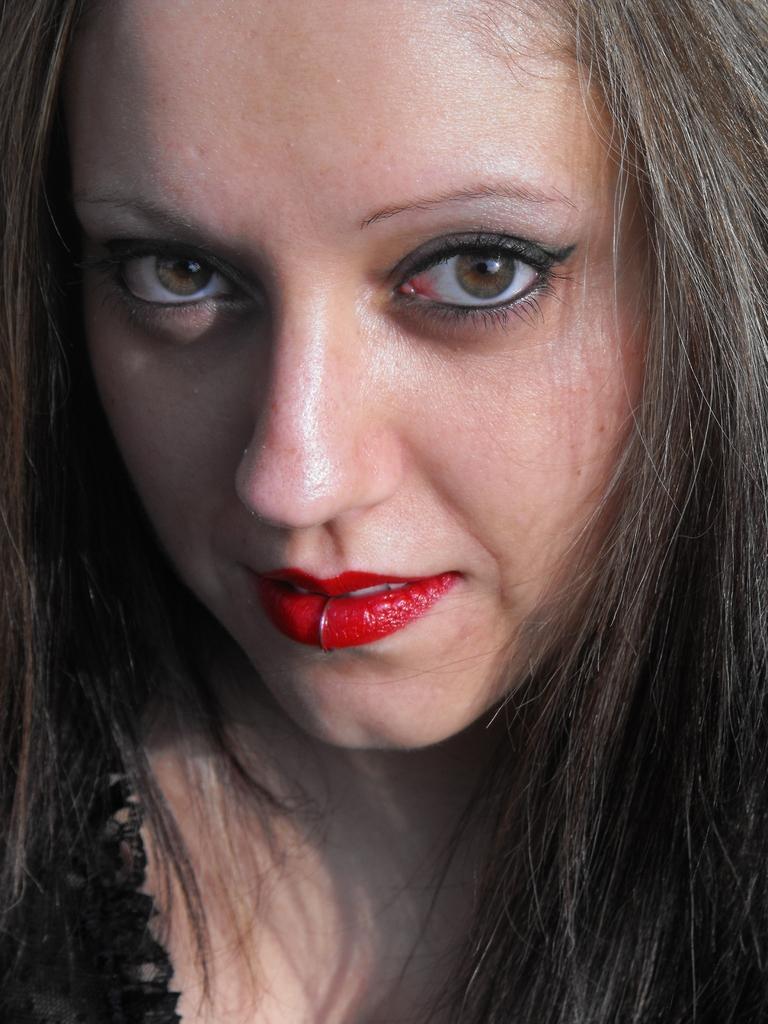How would you summarize this image in a sentence or two? In this image we can see a lady. 